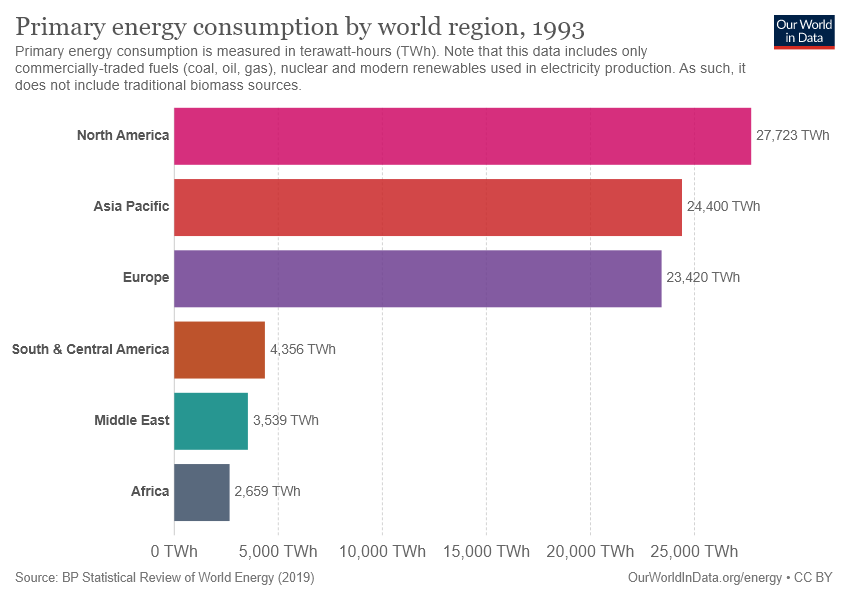Identify some key points in this picture. There is a difference between Asian Pacific and North American regions. The highest value of the place is located in North America. 